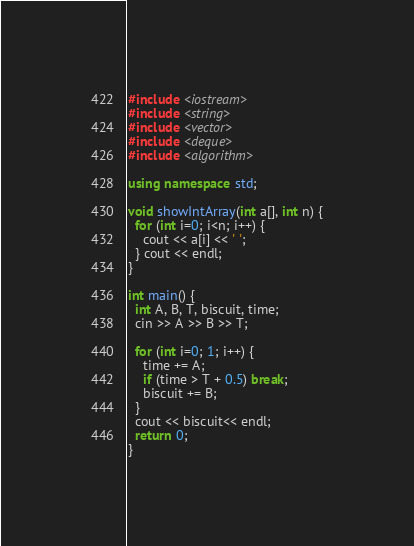Convert code to text. <code><loc_0><loc_0><loc_500><loc_500><_C++_>#include <iostream>
#include <string>
#include <vector>
#include <deque>
#include <algorithm>

using namespace std;

void showIntArray(int a[], int n) {
  for (int i=0; i<n; i++) {
    cout << a[i] << ' ';
  } cout << endl;
}

int main() {
  int A, B, T, biscuit, time;
  cin >> A >> B >> T;

  for (int i=0; 1; i++) {
    time += A;
    if (time > T + 0.5) break;
    biscuit += B;
  }
  cout << biscuit<< endl;
  return 0;
}</code> 